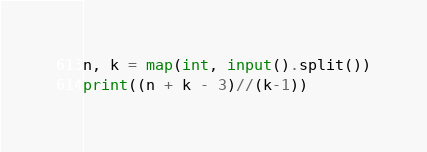<code> <loc_0><loc_0><loc_500><loc_500><_Python_>n, k = map(int, input().split())
print((n + k - 3)//(k-1))</code> 